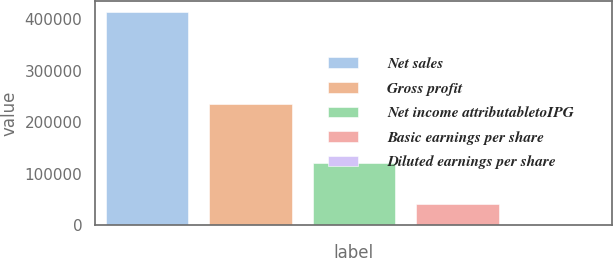Convert chart to OTSL. <chart><loc_0><loc_0><loc_500><loc_500><bar_chart><fcel>Net sales<fcel>Gross profit<fcel>Net income attributabletoIPG<fcel>Basic earnings per share<fcel>Diluted earnings per share<nl><fcel>413613<fcel>234975<fcel>121617<fcel>41363.3<fcel>2.21<nl></chart> 